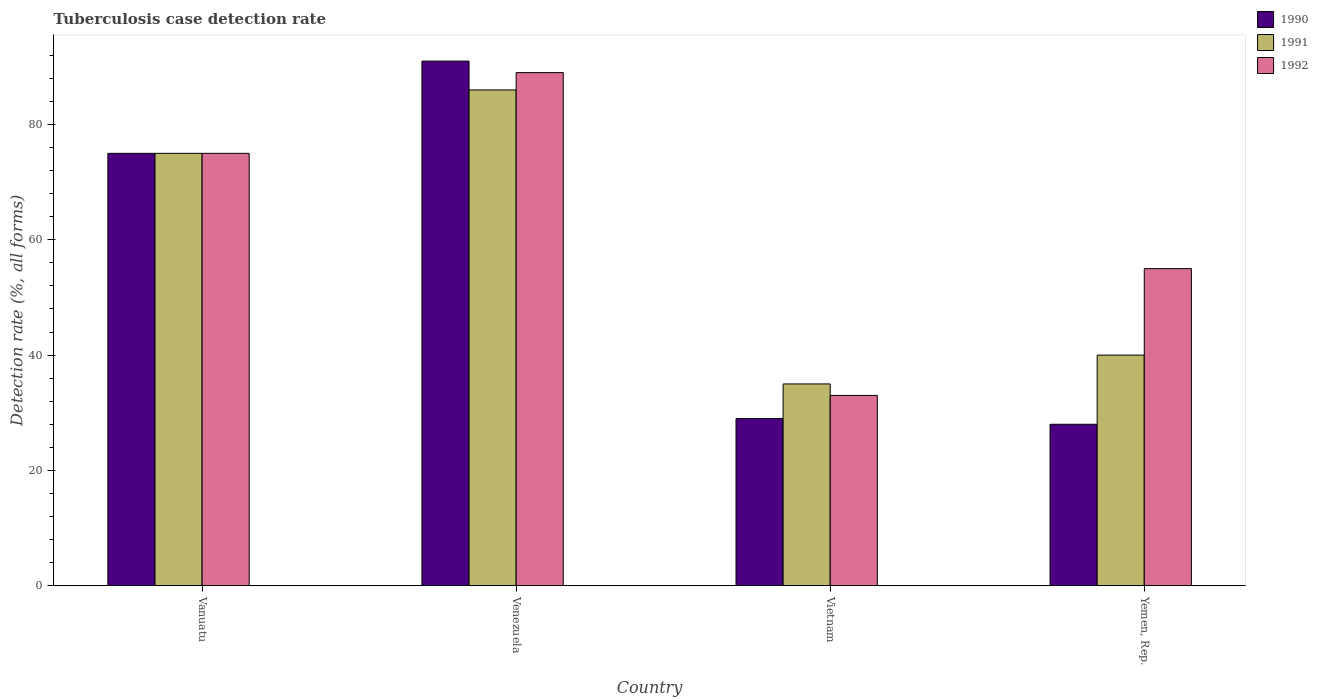How many groups of bars are there?
Offer a very short reply. 4. Are the number of bars per tick equal to the number of legend labels?
Your response must be concise. Yes. Are the number of bars on each tick of the X-axis equal?
Offer a very short reply. Yes. How many bars are there on the 2nd tick from the right?
Keep it short and to the point. 3. What is the label of the 1st group of bars from the left?
Ensure brevity in your answer.  Vanuatu. In which country was the tuberculosis case detection rate in in 1990 maximum?
Provide a succinct answer. Venezuela. In which country was the tuberculosis case detection rate in in 1992 minimum?
Offer a very short reply. Vietnam. What is the total tuberculosis case detection rate in in 1991 in the graph?
Offer a terse response. 236. What is the difference between the tuberculosis case detection rate in in 1991 in Yemen, Rep. and the tuberculosis case detection rate in in 1992 in Venezuela?
Keep it short and to the point. -49. What is the average tuberculosis case detection rate in in 1990 per country?
Offer a terse response. 55.75. What is the difference between the tuberculosis case detection rate in of/in 1990 and tuberculosis case detection rate in of/in 1991 in Yemen, Rep.?
Provide a short and direct response. -12. What is the ratio of the tuberculosis case detection rate in in 1991 in Vanuatu to that in Yemen, Rep.?
Ensure brevity in your answer.  1.88. What is the difference between the highest and the lowest tuberculosis case detection rate in in 1990?
Provide a succinct answer. 63. Is it the case that in every country, the sum of the tuberculosis case detection rate in in 1990 and tuberculosis case detection rate in in 1991 is greater than the tuberculosis case detection rate in in 1992?
Keep it short and to the point. Yes. How many bars are there?
Offer a terse response. 12. Are all the bars in the graph horizontal?
Give a very brief answer. No. Does the graph contain grids?
Give a very brief answer. No. Where does the legend appear in the graph?
Keep it short and to the point. Top right. How are the legend labels stacked?
Your answer should be compact. Vertical. What is the title of the graph?
Ensure brevity in your answer.  Tuberculosis case detection rate. Does "2011" appear as one of the legend labels in the graph?
Your response must be concise. No. What is the label or title of the X-axis?
Ensure brevity in your answer.  Country. What is the label or title of the Y-axis?
Give a very brief answer. Detection rate (%, all forms). What is the Detection rate (%, all forms) of 1991 in Vanuatu?
Give a very brief answer. 75. What is the Detection rate (%, all forms) of 1990 in Venezuela?
Your response must be concise. 91. What is the Detection rate (%, all forms) in 1992 in Venezuela?
Ensure brevity in your answer.  89. What is the Detection rate (%, all forms) in 1991 in Vietnam?
Keep it short and to the point. 35. What is the Detection rate (%, all forms) of 1991 in Yemen, Rep.?
Give a very brief answer. 40. What is the Detection rate (%, all forms) of 1992 in Yemen, Rep.?
Offer a very short reply. 55. Across all countries, what is the maximum Detection rate (%, all forms) of 1990?
Your answer should be compact. 91. Across all countries, what is the maximum Detection rate (%, all forms) of 1991?
Make the answer very short. 86. Across all countries, what is the maximum Detection rate (%, all forms) of 1992?
Give a very brief answer. 89. Across all countries, what is the minimum Detection rate (%, all forms) in 1992?
Give a very brief answer. 33. What is the total Detection rate (%, all forms) of 1990 in the graph?
Your answer should be very brief. 223. What is the total Detection rate (%, all forms) in 1991 in the graph?
Make the answer very short. 236. What is the total Detection rate (%, all forms) of 1992 in the graph?
Your response must be concise. 252. What is the difference between the Detection rate (%, all forms) in 1990 in Vanuatu and that in Vietnam?
Offer a very short reply. 46. What is the difference between the Detection rate (%, all forms) in 1992 in Vanuatu and that in Vietnam?
Give a very brief answer. 42. What is the difference between the Detection rate (%, all forms) in 1992 in Vanuatu and that in Yemen, Rep.?
Your response must be concise. 20. What is the difference between the Detection rate (%, all forms) in 1991 in Venezuela and that in Vietnam?
Keep it short and to the point. 51. What is the difference between the Detection rate (%, all forms) in 1992 in Venezuela and that in Vietnam?
Provide a short and direct response. 56. What is the difference between the Detection rate (%, all forms) in 1990 in Venezuela and that in Yemen, Rep.?
Offer a terse response. 63. What is the difference between the Detection rate (%, all forms) of 1992 in Venezuela and that in Yemen, Rep.?
Your answer should be compact. 34. What is the difference between the Detection rate (%, all forms) in 1992 in Vietnam and that in Yemen, Rep.?
Make the answer very short. -22. What is the difference between the Detection rate (%, all forms) of 1990 in Vanuatu and the Detection rate (%, all forms) of 1992 in Venezuela?
Provide a succinct answer. -14. What is the difference between the Detection rate (%, all forms) in 1990 in Vanuatu and the Detection rate (%, all forms) in 1992 in Vietnam?
Provide a short and direct response. 42. What is the difference between the Detection rate (%, all forms) of 1990 in Vanuatu and the Detection rate (%, all forms) of 1991 in Yemen, Rep.?
Keep it short and to the point. 35. What is the difference between the Detection rate (%, all forms) of 1990 in Vanuatu and the Detection rate (%, all forms) of 1992 in Yemen, Rep.?
Your answer should be very brief. 20. What is the difference between the Detection rate (%, all forms) of 1991 in Vanuatu and the Detection rate (%, all forms) of 1992 in Yemen, Rep.?
Give a very brief answer. 20. What is the difference between the Detection rate (%, all forms) in 1990 in Venezuela and the Detection rate (%, all forms) in 1991 in Vietnam?
Offer a very short reply. 56. What is the difference between the Detection rate (%, all forms) in 1991 in Venezuela and the Detection rate (%, all forms) in 1992 in Vietnam?
Your response must be concise. 53. What is the difference between the Detection rate (%, all forms) in 1990 in Venezuela and the Detection rate (%, all forms) in 1991 in Yemen, Rep.?
Provide a succinct answer. 51. What is the difference between the Detection rate (%, all forms) in 1990 in Venezuela and the Detection rate (%, all forms) in 1992 in Yemen, Rep.?
Give a very brief answer. 36. What is the difference between the Detection rate (%, all forms) in 1991 in Venezuela and the Detection rate (%, all forms) in 1992 in Yemen, Rep.?
Your answer should be compact. 31. What is the difference between the Detection rate (%, all forms) of 1990 in Vietnam and the Detection rate (%, all forms) of 1992 in Yemen, Rep.?
Provide a succinct answer. -26. What is the average Detection rate (%, all forms) of 1990 per country?
Keep it short and to the point. 55.75. What is the average Detection rate (%, all forms) in 1991 per country?
Ensure brevity in your answer.  59. What is the average Detection rate (%, all forms) of 1992 per country?
Offer a terse response. 63. What is the difference between the Detection rate (%, all forms) in 1990 and Detection rate (%, all forms) in 1991 in Vanuatu?
Ensure brevity in your answer.  0. What is the difference between the Detection rate (%, all forms) in 1991 and Detection rate (%, all forms) in 1992 in Vanuatu?
Make the answer very short. 0. What is the difference between the Detection rate (%, all forms) in 1990 and Detection rate (%, all forms) in 1991 in Venezuela?
Provide a short and direct response. 5. What is the difference between the Detection rate (%, all forms) of 1991 and Detection rate (%, all forms) of 1992 in Vietnam?
Make the answer very short. 2. What is the difference between the Detection rate (%, all forms) in 1990 and Detection rate (%, all forms) in 1992 in Yemen, Rep.?
Offer a very short reply. -27. What is the ratio of the Detection rate (%, all forms) in 1990 in Vanuatu to that in Venezuela?
Ensure brevity in your answer.  0.82. What is the ratio of the Detection rate (%, all forms) of 1991 in Vanuatu to that in Venezuela?
Offer a terse response. 0.87. What is the ratio of the Detection rate (%, all forms) of 1992 in Vanuatu to that in Venezuela?
Make the answer very short. 0.84. What is the ratio of the Detection rate (%, all forms) of 1990 in Vanuatu to that in Vietnam?
Offer a very short reply. 2.59. What is the ratio of the Detection rate (%, all forms) in 1991 in Vanuatu to that in Vietnam?
Ensure brevity in your answer.  2.14. What is the ratio of the Detection rate (%, all forms) of 1992 in Vanuatu to that in Vietnam?
Provide a short and direct response. 2.27. What is the ratio of the Detection rate (%, all forms) of 1990 in Vanuatu to that in Yemen, Rep.?
Ensure brevity in your answer.  2.68. What is the ratio of the Detection rate (%, all forms) in 1991 in Vanuatu to that in Yemen, Rep.?
Offer a terse response. 1.88. What is the ratio of the Detection rate (%, all forms) in 1992 in Vanuatu to that in Yemen, Rep.?
Your answer should be compact. 1.36. What is the ratio of the Detection rate (%, all forms) of 1990 in Venezuela to that in Vietnam?
Provide a short and direct response. 3.14. What is the ratio of the Detection rate (%, all forms) in 1991 in Venezuela to that in Vietnam?
Offer a terse response. 2.46. What is the ratio of the Detection rate (%, all forms) in 1992 in Venezuela to that in Vietnam?
Your response must be concise. 2.7. What is the ratio of the Detection rate (%, all forms) of 1990 in Venezuela to that in Yemen, Rep.?
Your response must be concise. 3.25. What is the ratio of the Detection rate (%, all forms) of 1991 in Venezuela to that in Yemen, Rep.?
Your answer should be very brief. 2.15. What is the ratio of the Detection rate (%, all forms) of 1992 in Venezuela to that in Yemen, Rep.?
Keep it short and to the point. 1.62. What is the ratio of the Detection rate (%, all forms) of 1990 in Vietnam to that in Yemen, Rep.?
Make the answer very short. 1.04. What is the ratio of the Detection rate (%, all forms) of 1991 in Vietnam to that in Yemen, Rep.?
Offer a very short reply. 0.88. What is the difference between the highest and the second highest Detection rate (%, all forms) in 1990?
Your answer should be compact. 16. What is the difference between the highest and the second highest Detection rate (%, all forms) of 1991?
Give a very brief answer. 11. What is the difference between the highest and the second highest Detection rate (%, all forms) in 1992?
Your answer should be compact. 14. What is the difference between the highest and the lowest Detection rate (%, all forms) of 1990?
Offer a very short reply. 63. What is the difference between the highest and the lowest Detection rate (%, all forms) in 1992?
Provide a succinct answer. 56. 